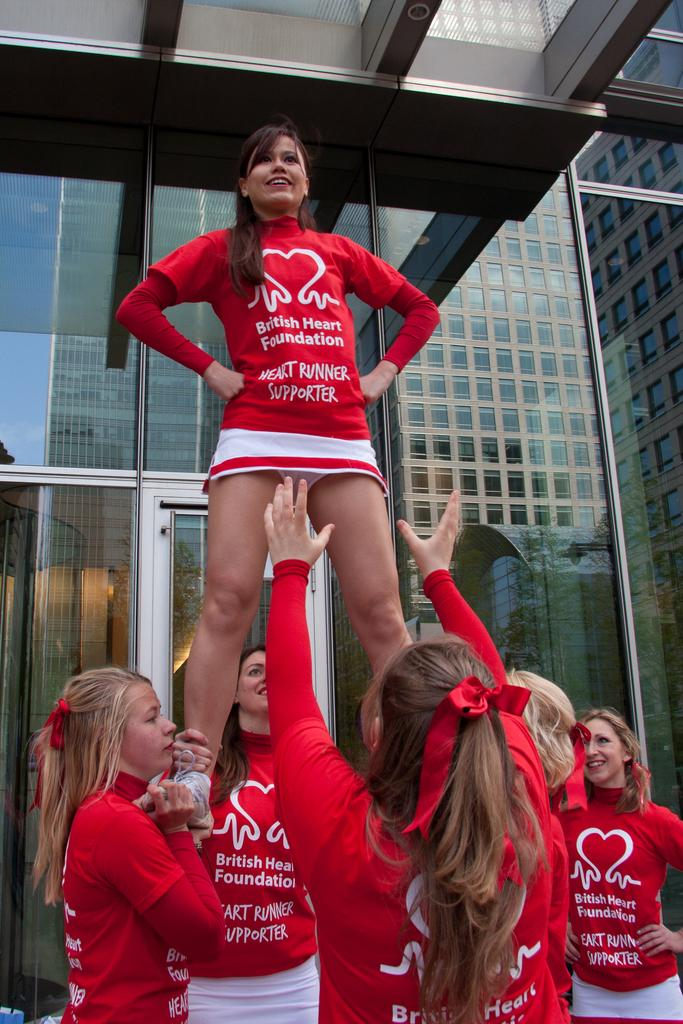<image>
Describe the image concisely. British Heart Foundation Cheerleaders doing a dangerous stunt. 